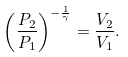<formula> <loc_0><loc_0><loc_500><loc_500>\left ( { \frac { P _ { 2 } } { P _ { 1 } } } \right ) ^ { - { \frac { 1 } { \gamma } } } = { \frac { V _ { 2 } } { V _ { 1 } } } .</formula> 